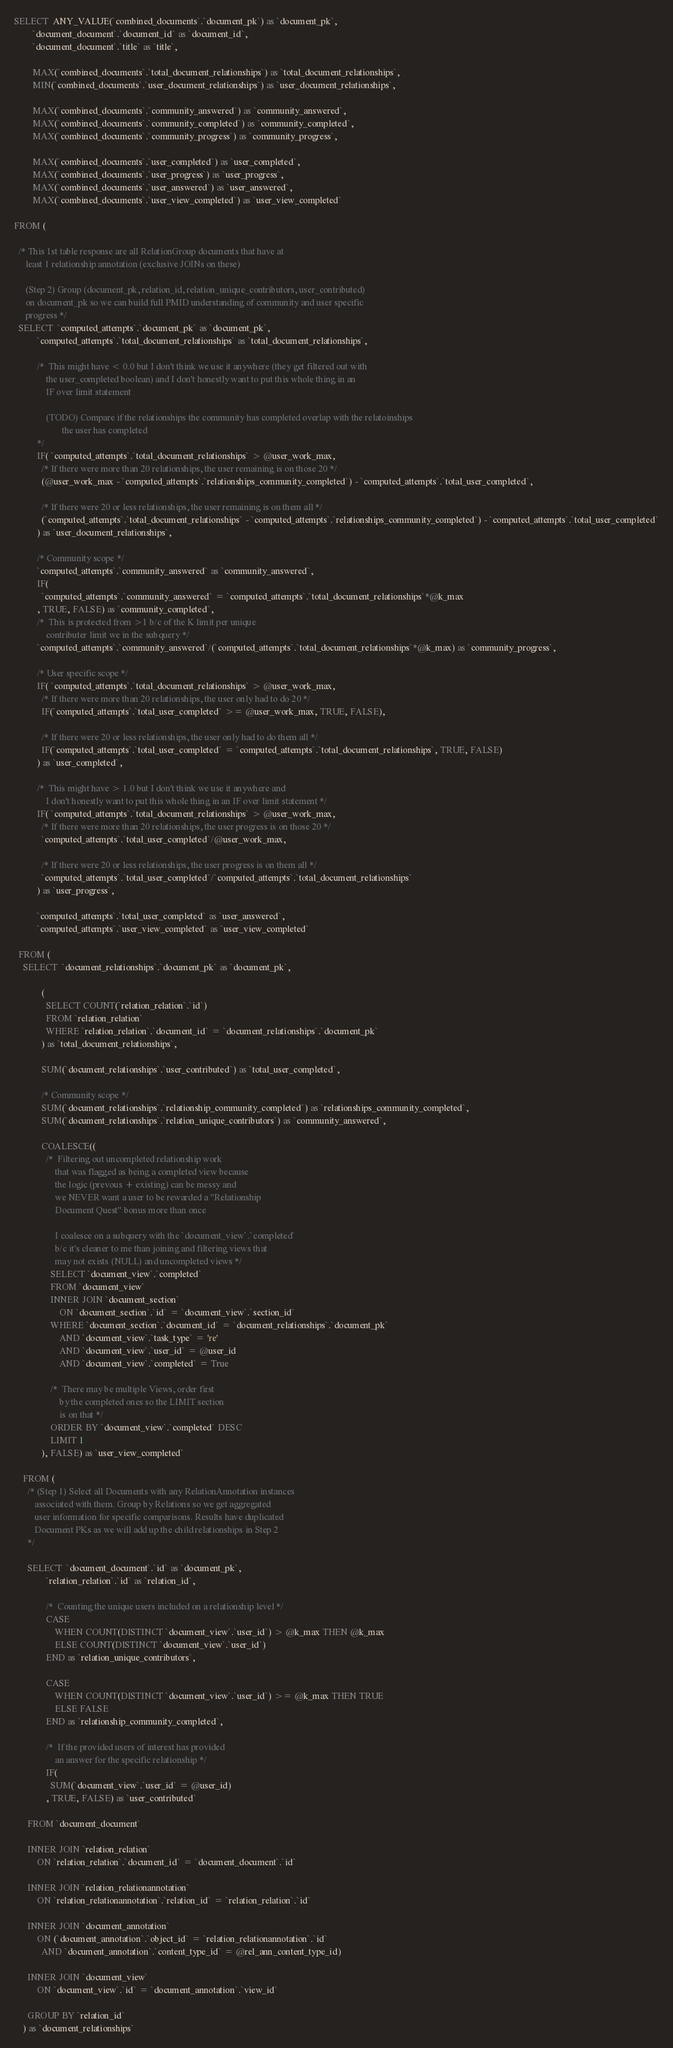<code> <loc_0><loc_0><loc_500><loc_500><_SQL_>SELECT  ANY_VALUE(`combined_documents`.`document_pk`) as `document_pk`,
        `document_document`.`document_id` as `document_id`,
        `document_document`.`title` as `title`,

        MAX(`combined_documents`.`total_document_relationships`) as `total_document_relationships`,
        MIN(`combined_documents`.`user_document_relationships`) as `user_document_relationships`,

        MAX(`combined_documents`.`community_answered`) as `community_answered`,
        MAX(`combined_documents`.`community_completed`) as `community_completed`,
        MAX(`combined_documents`.`community_progress`) as `community_progress`,

        MAX(`combined_documents`.`user_completed`) as `user_completed`,
        MAX(`combined_documents`.`user_progress`) as `user_progress`,
        MAX(`combined_documents`.`user_answered`) as `user_answered`,
        MAX(`combined_documents`.`user_view_completed`) as `user_view_completed`

FROM (

  /* This 1st table response are all RelationGroup documents that have at
     least 1 relationship annotation (exclusive JOINs on these)

     (Step 2) Group (document_pk, relation_id, relation_unique_contributors, user_contributed)
     on document_pk so we can build full PMID understanding of community and user specific
     progress */
  SELECT  `computed_attempts`.`document_pk` as `document_pk`,
          `computed_attempts`.`total_document_relationships` as `total_document_relationships`,

          /*  This might have < 0.0 but I don't think we use it anywhere (they get filtered out with
              the user_completed boolean) and I don't honestly want to put this whole thing in an
              IF over limit statement

              (TODO) Compare if the relationships the community has completed overlap with the relatoinships
                     the user has completed
          */
          IF( `computed_attempts`.`total_document_relationships` > @user_work_max,
            /* If there were more than 20 relationships, the user remaining is on those 20 */
            (@user_work_max - `computed_attempts`.`relationships_community_completed`) - `computed_attempts`.`total_user_completed`,

            /* If there were 20 or less relationships, the user remaining is on them all */
            (`computed_attempts`.`total_document_relationships` - `computed_attempts`.`relationships_community_completed`) - `computed_attempts`.`total_user_completed`
          ) as `user_document_relationships`,

          /* Community scope */
          `computed_attempts`.`community_answered` as `community_answered`,
          IF(
            `computed_attempts`.`community_answered` = `computed_attempts`.`total_document_relationships`*@k_max
          , TRUE, FALSE) as `community_completed`,
          /*  This is protected from >1 b/c of the K limit per unique
              contributer limit we in the subquery */
          `computed_attempts`.`community_answered`/(`computed_attempts`.`total_document_relationships`*@k_max) as `community_progress`,

          /* User specific scope */
          IF( `computed_attempts`.`total_document_relationships` > @user_work_max,
            /* If there were more than 20 relationships, the user only had to do 20 */
            IF(`computed_attempts`.`total_user_completed` >= @user_work_max, TRUE, FALSE),

            /* If there were 20 or less relationships, the user only had to do them all */
            IF(`computed_attempts`.`total_user_completed` = `computed_attempts`.`total_document_relationships`, TRUE, FALSE)
          ) as `user_completed`,

          /*  This might have > 1.0 but I don't think we use it anywhere and
              I don't honestly want to put this whole thing in an IF over limit statement */
          IF( `computed_attempts`.`total_document_relationships` > @user_work_max,
            /* If there were more than 20 relationships, the user progress is on those 20 */
            `computed_attempts`.`total_user_completed`/@user_work_max,

            /* If there were 20 or less relationships, the user progress is on them all */
            `computed_attempts`.`total_user_completed`/`computed_attempts`.`total_document_relationships`
          ) as `user_progress`,

          `computed_attempts`.`total_user_completed` as `user_answered`,
          `computed_attempts`.`user_view_completed` as `user_view_completed`

  FROM (
    SELECT  `document_relationships`.`document_pk` as `document_pk`,

            (
              SELECT COUNT(`relation_relation`.`id`)
              FROM `relation_relation`
              WHERE `relation_relation`.`document_id` = `document_relationships`.`document_pk`
            ) as `total_document_relationships`,

            SUM(`document_relationships`.`user_contributed`) as `total_user_completed`,

            /* Community scope */
            SUM(`document_relationships`.`relationship_community_completed`) as `relationships_community_completed`,
            SUM(`document_relationships`.`relation_unique_contributors`) as `community_answered`,

            COALESCE((
              /*  Filtering out uncompleted relationship work
                  that was flagged as being a completed view because
                  the logic (prevous + existing) can be messy and
                  we NEVER want a user to be rewarded a "Relationship
                  Document Quest" bonus more than once

                  I coalesce on a subquery with the `document_view`.`completed`
                  b/c it's cleaner to me than joining and filtering views that
                  may not exists (NULL) and uncompleted views */
                SELECT `document_view`.`completed`
                FROM `document_view`
                INNER JOIN `document_section`
                    ON `document_section`.`id` = `document_view`.`section_id`
                WHERE `document_section`.`document_id` = `document_relationships`.`document_pk`
                    AND `document_view`.`task_type` = 're'
                    AND `document_view`.`user_id` = @user_id
                    AND `document_view`.`completed` = True

                /*  There may be multiple Views, order first
                    by the completed ones so the LIMIT section
                    is on that */
                ORDER BY `document_view`.`completed` DESC
                LIMIT 1
            ), FALSE) as `user_view_completed`

    FROM (
      /* (Step 1) Select all Documents with any RelationAnnotation instances
         associated with them. Group by Relations so we get aggregated
         user information for specific comparisons. Results have duplicated
         Document PKs as we will add up the child relationships in Step 2
      */

      SELECT  `document_document`.`id` as `document_pk`,
              `relation_relation`.`id` as `relation_id`,

              /*  Counting the unique users included on a relationship level */
              CASE
                  WHEN COUNT(DISTINCT `document_view`.`user_id`) > @k_max THEN @k_max
                  ELSE COUNT(DISTINCT `document_view`.`user_id`)
              END as `relation_unique_contributors`,

              CASE
                  WHEN COUNT(DISTINCT `document_view`.`user_id`) >= @k_max THEN TRUE
                  ELSE FALSE
              END as `relationship_community_completed`,

              /*  If the provided users of interest has provided
                  an answer for the specific relationship */
              IF(
                SUM(`document_view`.`user_id` = @user_id)
              , TRUE, FALSE) as `user_contributed`

      FROM `document_document`

      INNER JOIN `relation_relation`
          ON `relation_relation`.`document_id` = `document_document`.`id`

      INNER JOIN `relation_relationannotation`
          ON `relation_relationannotation`.`relation_id` = `relation_relation`.`id`

      INNER JOIN `document_annotation`
          ON (`document_annotation`.`object_id` = `relation_relationannotation`.`id`
            AND `document_annotation`.`content_type_id` = @rel_ann_content_type_id)

      INNER JOIN `document_view`
          ON `document_view`.`id` = `document_annotation`.`view_id`

      GROUP BY `relation_id`
    ) as `document_relationships`
</code> 